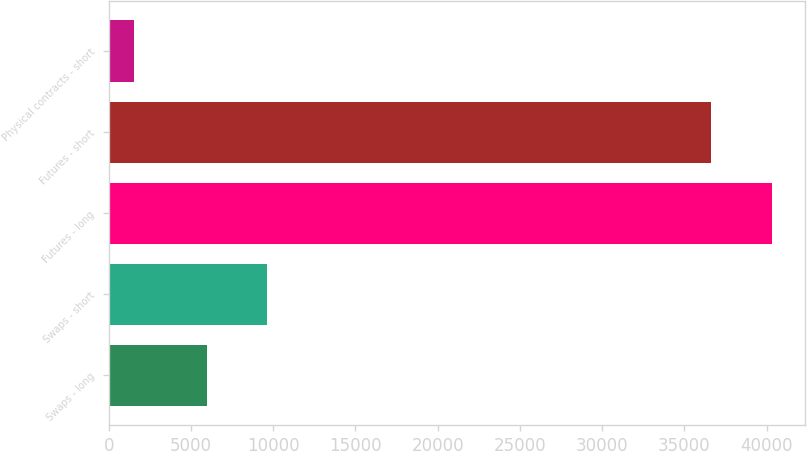<chart> <loc_0><loc_0><loc_500><loc_500><bar_chart><fcel>Swaps - long<fcel>Swaps - short<fcel>Futures - long<fcel>Futures - short<fcel>Physical contracts - short<nl><fcel>5961<fcel>9624.7<fcel>40300.7<fcel>36637<fcel>1564<nl></chart> 